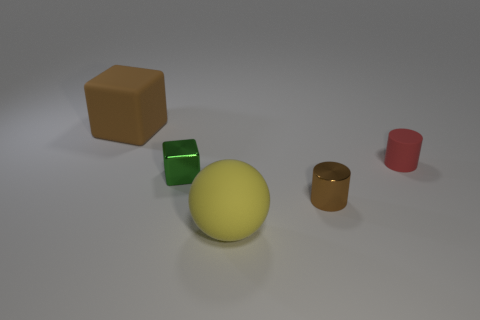Subtract all spheres. How many objects are left? 4 Add 3 green blocks. How many green blocks are left? 4 Add 4 large green shiny cylinders. How many large green shiny cylinders exist? 4 Add 1 large blue cubes. How many objects exist? 6 Subtract 1 green cubes. How many objects are left? 4 Subtract 1 blocks. How many blocks are left? 1 Subtract all yellow cubes. Subtract all yellow balls. How many cubes are left? 2 Subtract all blue cylinders. How many brown cubes are left? 1 Subtract all matte cylinders. Subtract all blue blocks. How many objects are left? 4 